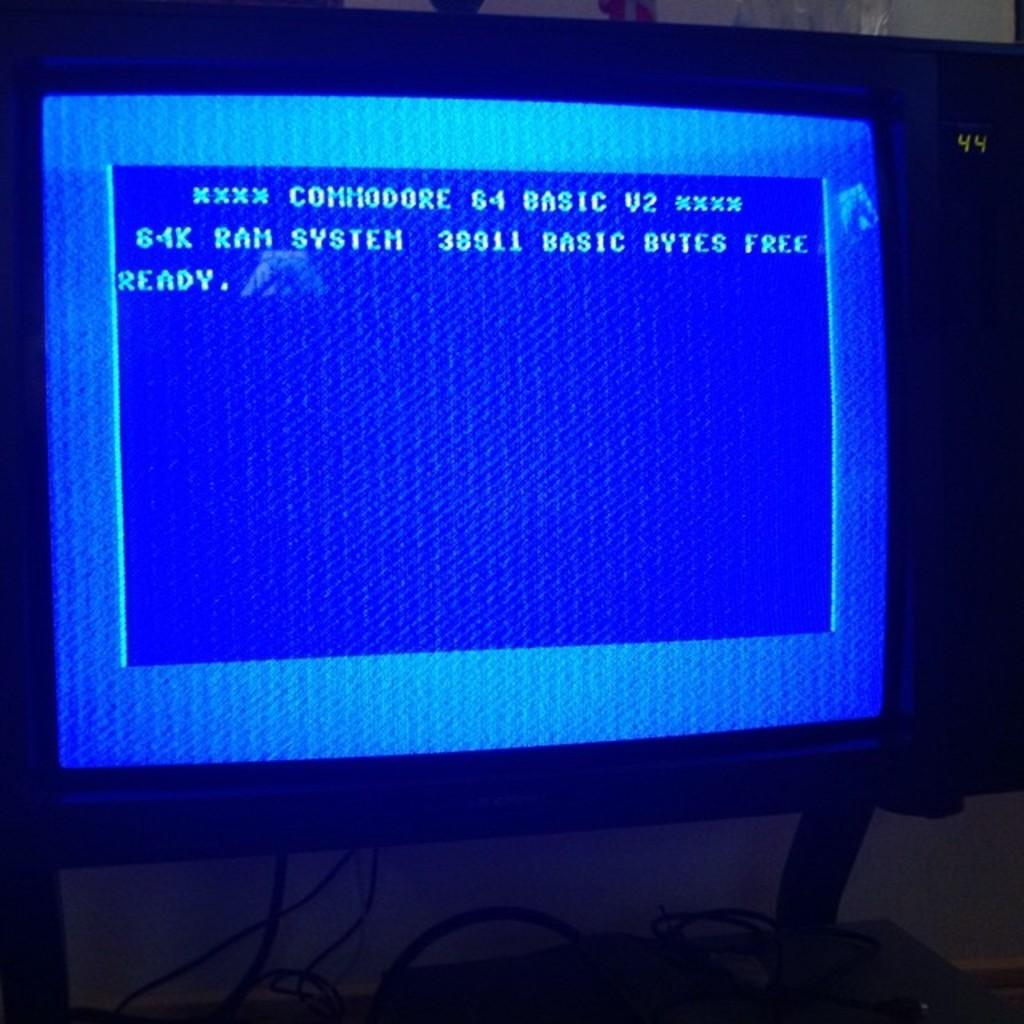<image>
Give a short and clear explanation of the subsequent image. A monitor displaying the "ready" screen of a Commodore 64 computer 